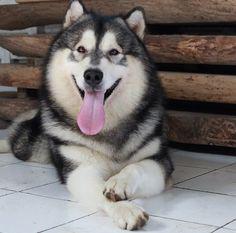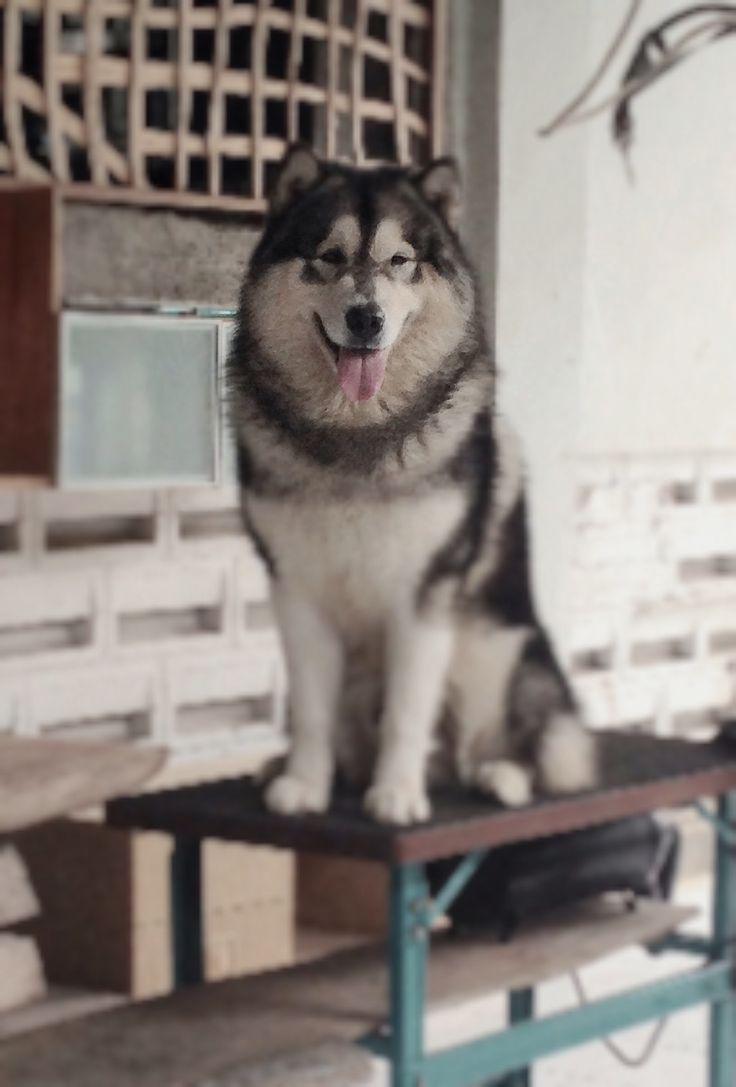The first image is the image on the left, the second image is the image on the right. Given the left and right images, does the statement "There is at least one dog on top of a table." hold true? Answer yes or no. Yes. The first image is the image on the left, the second image is the image on the right. Examine the images to the left and right. Is the description "The right image shows a husky dog perched atop a rectangular table in front of something with criss-crossing lines." accurate? Answer yes or no. Yes. 